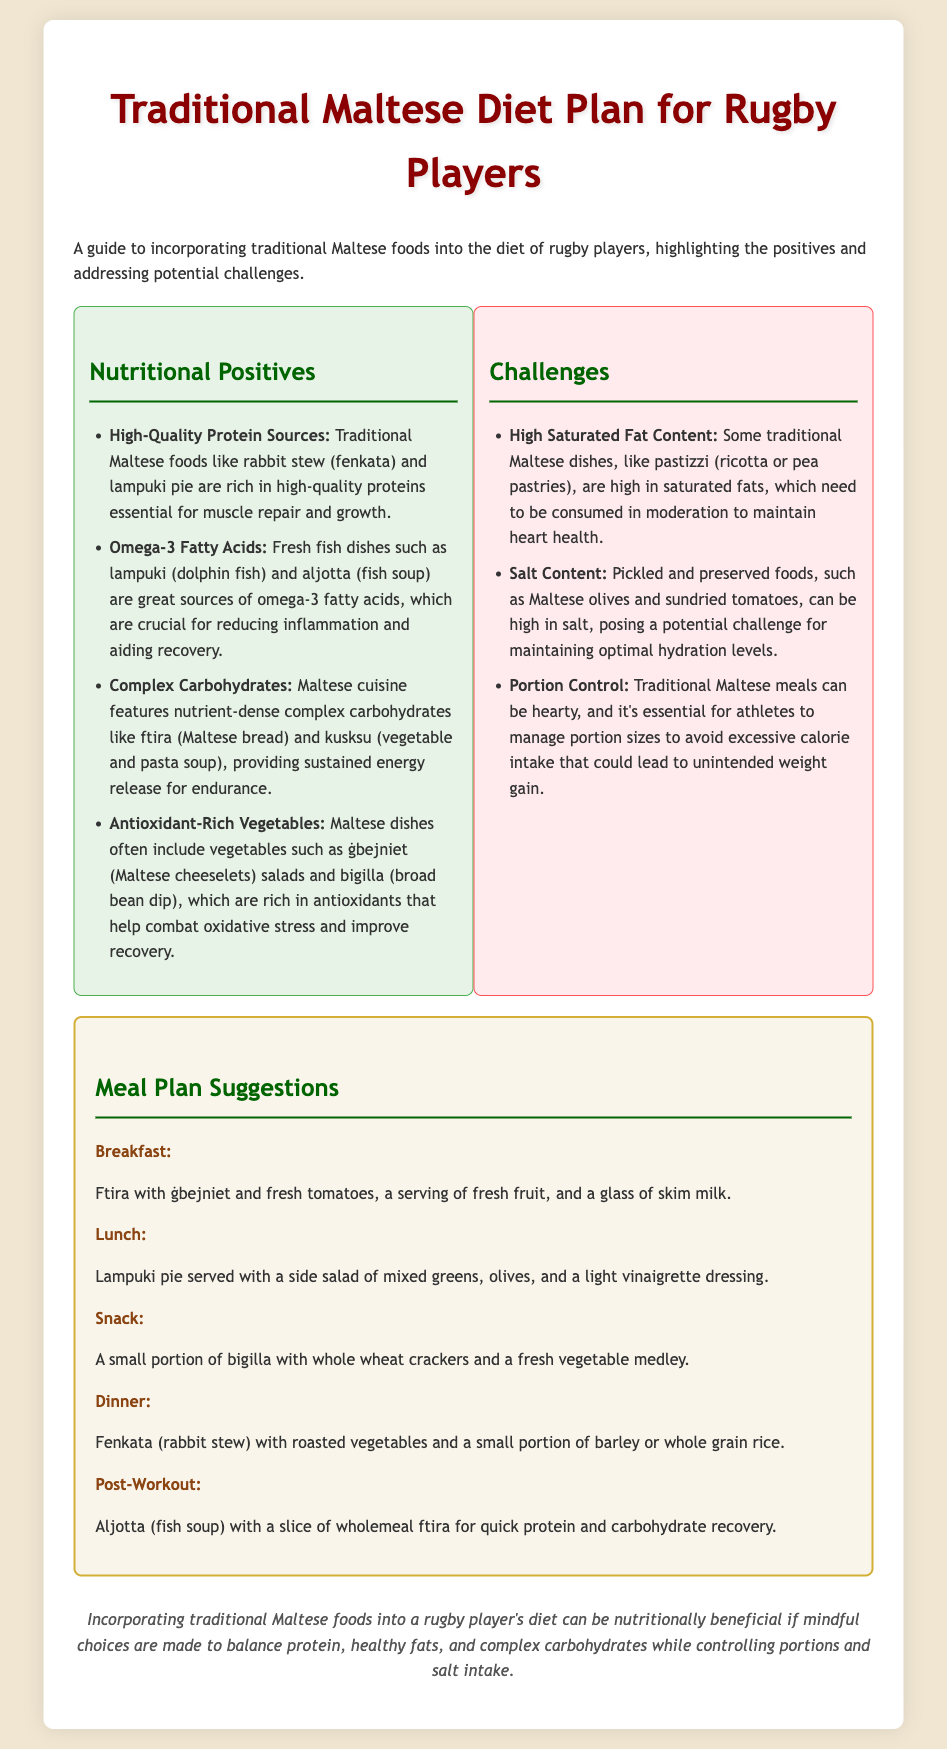What are two high-quality protein sources in the Maltese diet? The document lists rabbit stew (fenkata) and lampuki pie as high-quality protein sources.
Answer: rabbit stew, lampuki pie What problem is associated with pickled foods? The document mentions that pickled and preserved foods can be high in salt, posing a challenge for hydration.
Answer: high salt content What are complex carbohydrates mentioned in the meal plan? The document refers to ftira (Maltese bread) and kusksu (vegetable and pasta soup) as complex carbohydrates.
Answer: ftira, kusksu What is a recommended post-workout meal? The document states that aljotta (fish soup) with a slice of wholemeal ftira is suggested for post-workout recovery.
Answer: aljotta, wholemeal ftira How many main meals are suggested in the meal plan? The document outlines breakfast, lunch, snack, dinner, and post-workout meals, making a total of five.
Answer: five What is a traditional dish that is high in saturated fat? The document lists pastizzi as a traditional dish that is high in saturated fats.
Answer: pastizzi What should athletes manage to avoid weight gain? The document emphasizes the need for athletes to manage portion sizes to avoid excessive calorie intake.
Answer: portion sizes What is the primary conclusion of the document? The document concludes that traditional Maltese foods can be beneficial if mindful choices are made regarding nutrition and portion control.
Answer: mindful choices 